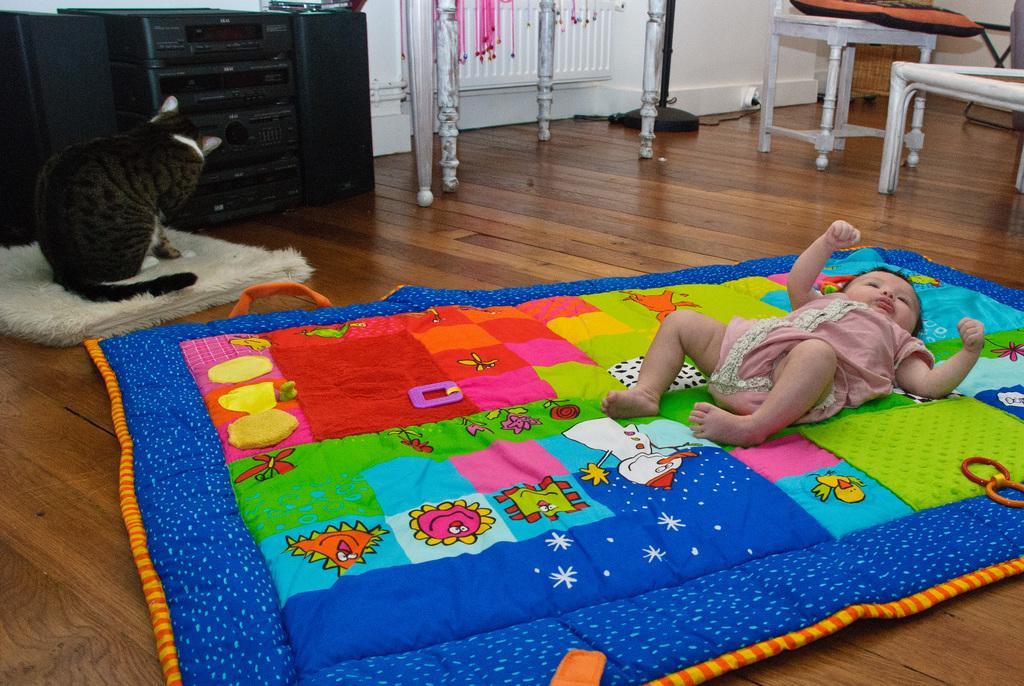Can you describe this image briefly? In this image there is a baby laying on the colorful carpet which is on the floor, there is a dog in another carpet , and in the back ground there is tape recorder, speakers, table, chairs, bag , stand. 